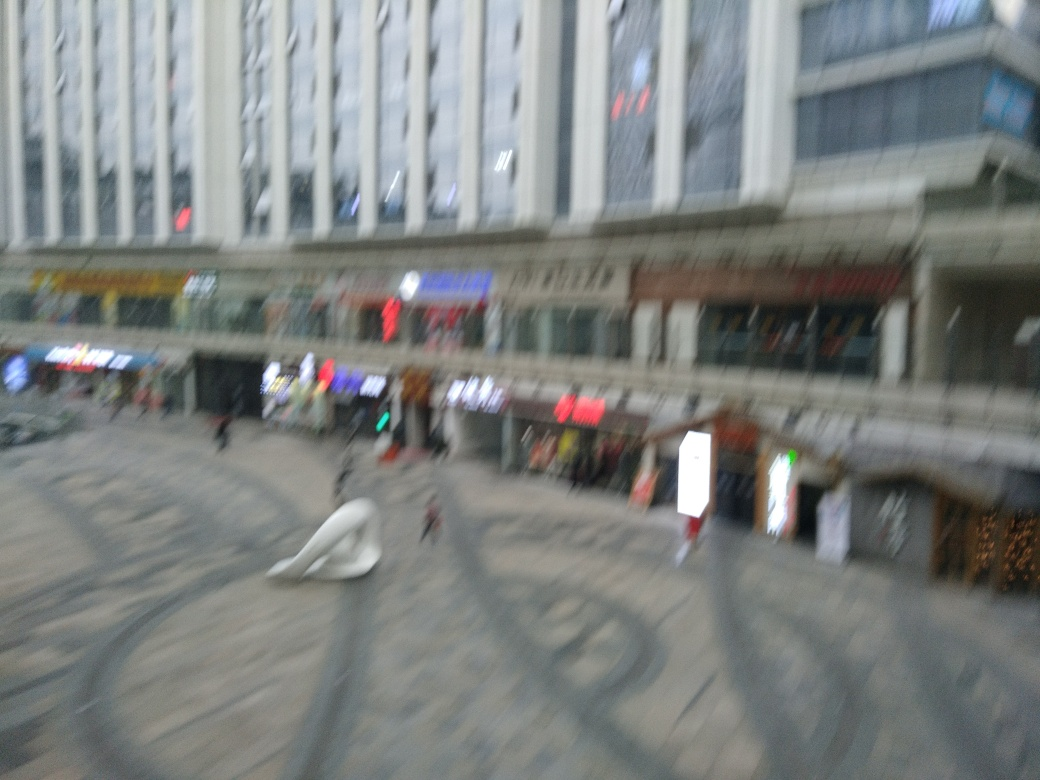Can you describe the architectural style of the building in the image? Although the blurred nature of the image makes it difficult to discern details, the building exhibits modern architectural characteristics with its geometric lines and possibly large glass windows, hinting at a contemporary urban design. 